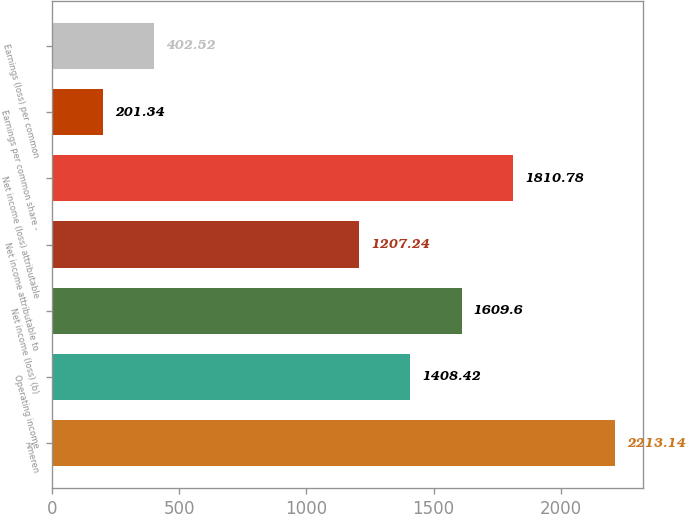Convert chart. <chart><loc_0><loc_0><loc_500><loc_500><bar_chart><fcel>Ameren<fcel>Operating income<fcel>Net income (loss) (b)<fcel>Net income attributable to<fcel>Net income (loss) attributable<fcel>Earnings per common share -<fcel>Earnings (loss) per common<nl><fcel>2213.14<fcel>1408.42<fcel>1609.6<fcel>1207.24<fcel>1810.78<fcel>201.34<fcel>402.52<nl></chart> 